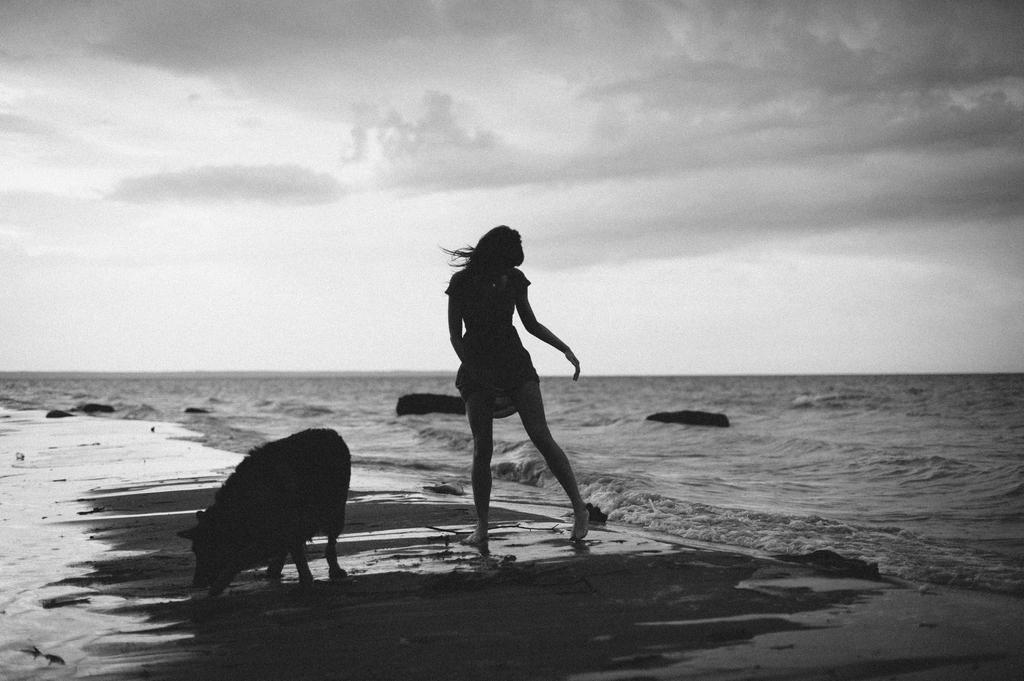What is present in the image along with the waves? There is a person and an animal in the image. Can you describe the animal in the image? The animal in the image is not specified, but it is present along with the person. What is the environment like in the image? The environment in the image features waves and objects in the water. How many chickens can be seen in the image? There is no mention of chickens in the image; it features a person, an unspecified animal, waves, and objects in the water. 